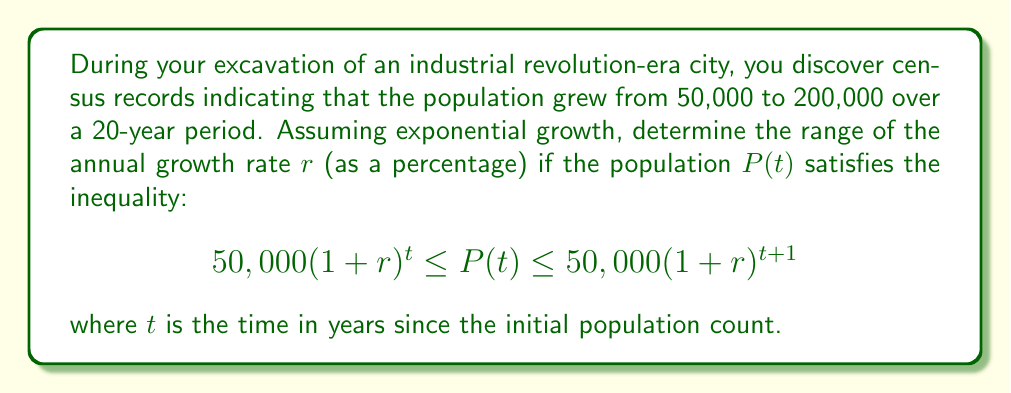Solve this math problem. 1) We know that after 20 years, the population reached 200,000. Let's use this information in our inequality:

   $$50,000(1+r)^{20} \leq 200,000 \leq 50,000(1+r)^{21}$$

2) Divide all parts by 50,000:

   $$(1+r)^{20} \leq 4 \leq (1+r)^{21}$$

3) For the left inequality:
   $(1+r)^{20} \leq 4$
   Take the 20th root of both sides:
   $1+r \leq \sqrt[20]{4} = 4^{1/20}$
   Subtract 1 from both sides:
   $r \leq 4^{1/20} - 1$

4) For the right inequality:
   $4 \leq (1+r)^{21}$
   Take the 21st root of both sides:
   $\sqrt[21]{4} \leq 1+r$
   Subtract 1 from both sides:
   $\sqrt[21]{4} - 1 \leq r$

5) Combining the results from steps 3 and 4:

   $\sqrt[21]{4} - 1 \leq r \leq 4^{1/20} - 1$

6) Calculate the values:
   $\sqrt[21]{4} - 1 \approx 0.0661$
   $4^{1/20} - 1 \approx 0.0699$

7) Convert to percentages:
   $6.61\% \leq r \leq 6.99\%$
Answer: $6.61\% \leq r \leq 6.99\%$ 